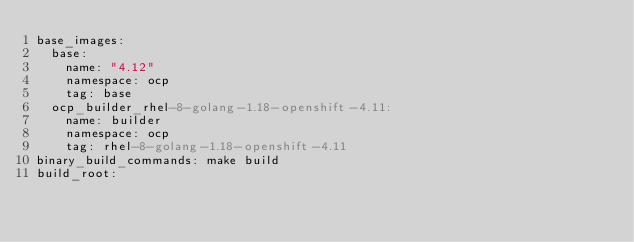Convert code to text. <code><loc_0><loc_0><loc_500><loc_500><_YAML_>base_images:
  base:
    name: "4.12"
    namespace: ocp
    tag: base
  ocp_builder_rhel-8-golang-1.18-openshift-4.11:
    name: builder
    namespace: ocp
    tag: rhel-8-golang-1.18-openshift-4.11
binary_build_commands: make build
build_root:</code> 